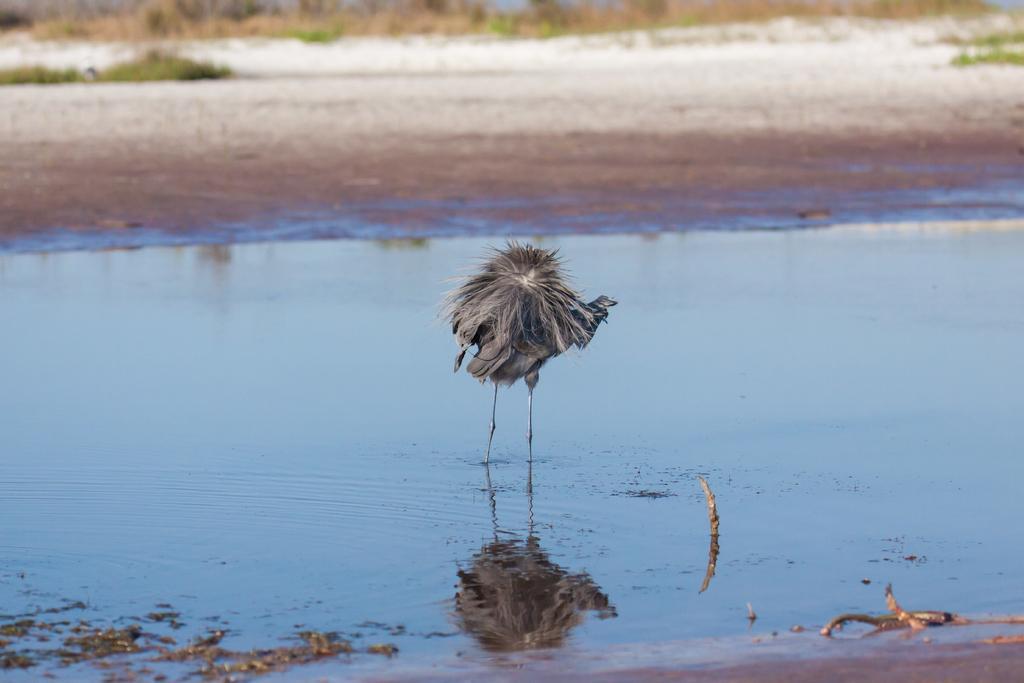Could you give a brief overview of what you see in this image? In this image we can see a bird in the water. On the backside we can see some plants. 